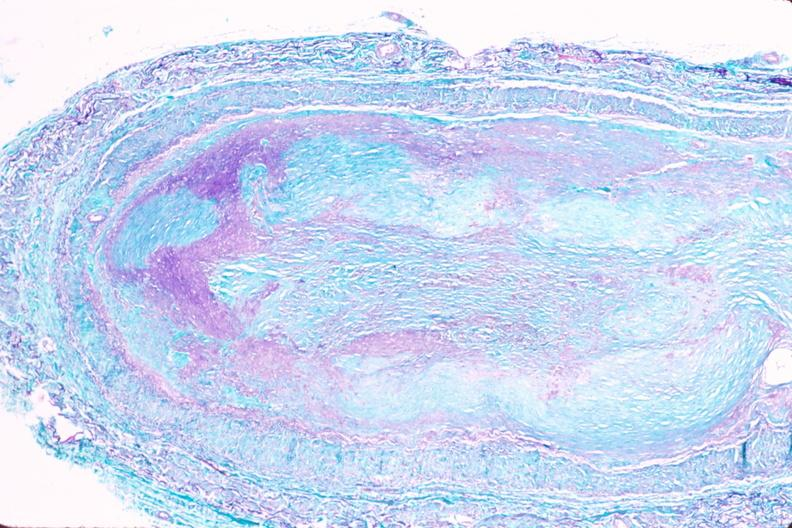does this image show saphenous vein graft sclerosis?
Answer the question using a single word or phrase. Yes 